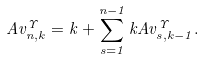<formula> <loc_0><loc_0><loc_500><loc_500>A v _ { n , k } ^ { \Upsilon } = k + \sum _ { s = 1 } ^ { n - 1 } k A v _ { s , k - 1 } ^ { \Upsilon } .</formula> 